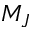<formula> <loc_0><loc_0><loc_500><loc_500>M _ { J }</formula> 